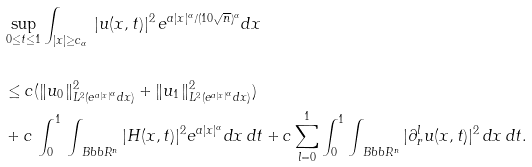<formula> <loc_0><loc_0><loc_500><loc_500>& \sup _ { 0 \leq t \leq 1 } \int _ { | x | \geq c _ { \alpha } } \, | u ( x , t ) | ^ { 2 } \, e ^ { a | x | ^ { \alpha } / ( 1 0 \sqrt { n } ) ^ { \alpha } } d x \\ \\ & \leq c ( \| u _ { 0 } \| ^ { 2 } _ { L ^ { 2 } ( e ^ { a | x | ^ { \alpha } } d x ) } + \| u _ { 1 } \| ^ { 2 } _ { L ^ { 2 } ( e ^ { a | x | ^ { \alpha } } d x ) } ) \\ & + c \, \int _ { 0 } ^ { 1 } \, \int _ { \ B b b R ^ { n } } | H ( x , t ) | ^ { 2 } e ^ { a | x | ^ { \alpha } } d x \, d t + c \sum _ { l = 0 } ^ { 1 } \int _ { 0 } ^ { 1 } \int _ { \ B b b R ^ { n } } | \partial ^ { l } _ { r } u ( x , t ) | ^ { 2 } \, d x \, d t .</formula> 